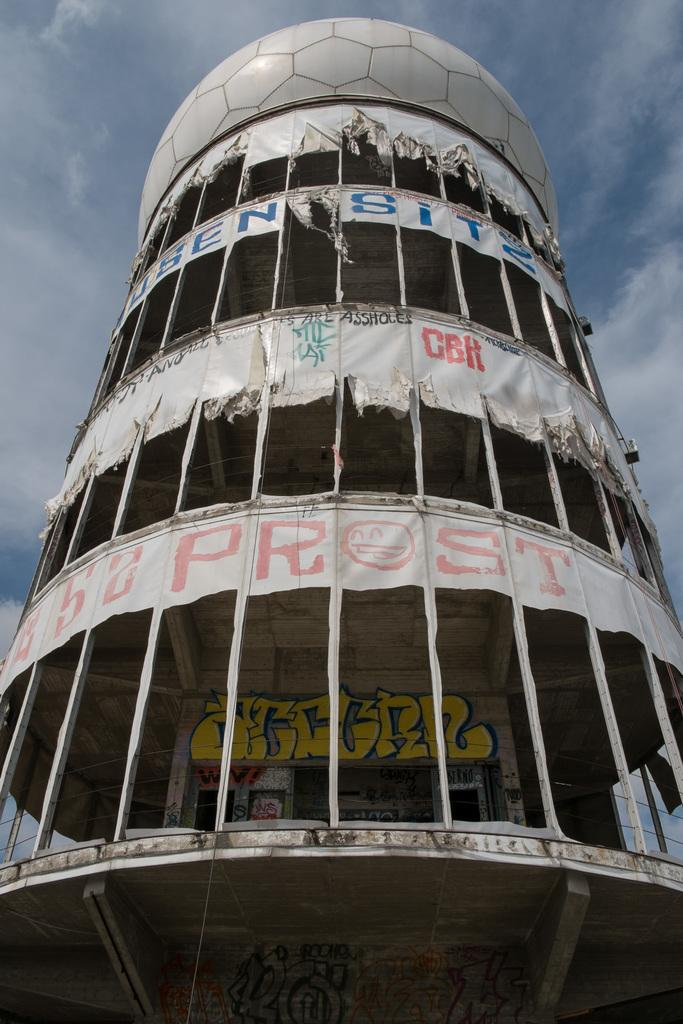What type of structure is visible in the image? There is a building in the image. What decorations can be seen in the image? There are banners in the image. Where is the painting located in the image? The painting is on a wall in the image. What can be seen in the background of the image? The sky is visible in the background of the image. What is the condition of the sky in the image? There are clouds in the sky. What type of patch is being sewn onto the birthday cake in the image? There is no patch or birthday cake present in the image. How fast are the people running in the image? There are no people running in the image. 